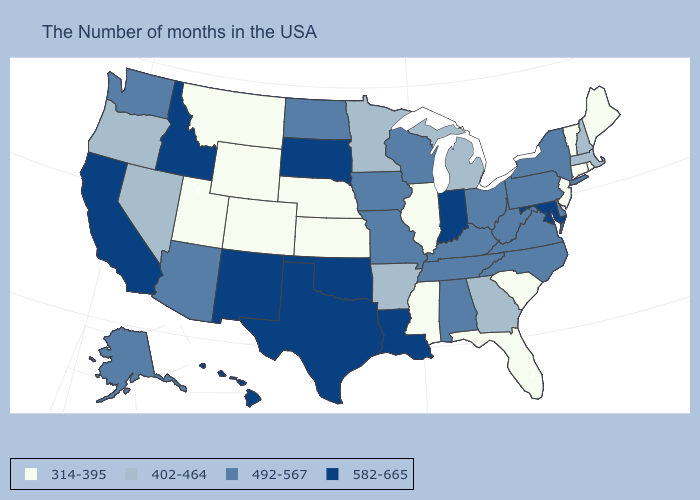Does the map have missing data?
Quick response, please. No. What is the lowest value in states that border South Carolina?
Be succinct. 402-464. Which states have the lowest value in the USA?
Short answer required. Maine, Rhode Island, Vermont, Connecticut, New Jersey, South Carolina, Florida, Illinois, Mississippi, Kansas, Nebraska, Wyoming, Colorado, Utah, Montana. Among the states that border Kansas , which have the highest value?
Keep it brief. Oklahoma. Which states have the lowest value in the USA?
Concise answer only. Maine, Rhode Island, Vermont, Connecticut, New Jersey, South Carolina, Florida, Illinois, Mississippi, Kansas, Nebraska, Wyoming, Colorado, Utah, Montana. Name the states that have a value in the range 492-567?
Be succinct. New York, Delaware, Pennsylvania, Virginia, North Carolina, West Virginia, Ohio, Kentucky, Alabama, Tennessee, Wisconsin, Missouri, Iowa, North Dakota, Arizona, Washington, Alaska. Name the states that have a value in the range 492-567?
Answer briefly. New York, Delaware, Pennsylvania, Virginia, North Carolina, West Virginia, Ohio, Kentucky, Alabama, Tennessee, Wisconsin, Missouri, Iowa, North Dakota, Arizona, Washington, Alaska. Does Massachusetts have the lowest value in the USA?
Be succinct. No. Name the states that have a value in the range 582-665?
Write a very short answer. Maryland, Indiana, Louisiana, Oklahoma, Texas, South Dakota, New Mexico, Idaho, California, Hawaii. Name the states that have a value in the range 492-567?
Quick response, please. New York, Delaware, Pennsylvania, Virginia, North Carolina, West Virginia, Ohio, Kentucky, Alabama, Tennessee, Wisconsin, Missouri, Iowa, North Dakota, Arizona, Washington, Alaska. What is the value of Kentucky?
Concise answer only. 492-567. Among the states that border Massachusetts , which have the lowest value?
Be succinct. Rhode Island, Vermont, Connecticut. Among the states that border Connecticut , which have the highest value?
Quick response, please. New York. Name the states that have a value in the range 492-567?
Quick response, please. New York, Delaware, Pennsylvania, Virginia, North Carolina, West Virginia, Ohio, Kentucky, Alabama, Tennessee, Wisconsin, Missouri, Iowa, North Dakota, Arizona, Washington, Alaska. Name the states that have a value in the range 402-464?
Answer briefly. Massachusetts, New Hampshire, Georgia, Michigan, Arkansas, Minnesota, Nevada, Oregon. 